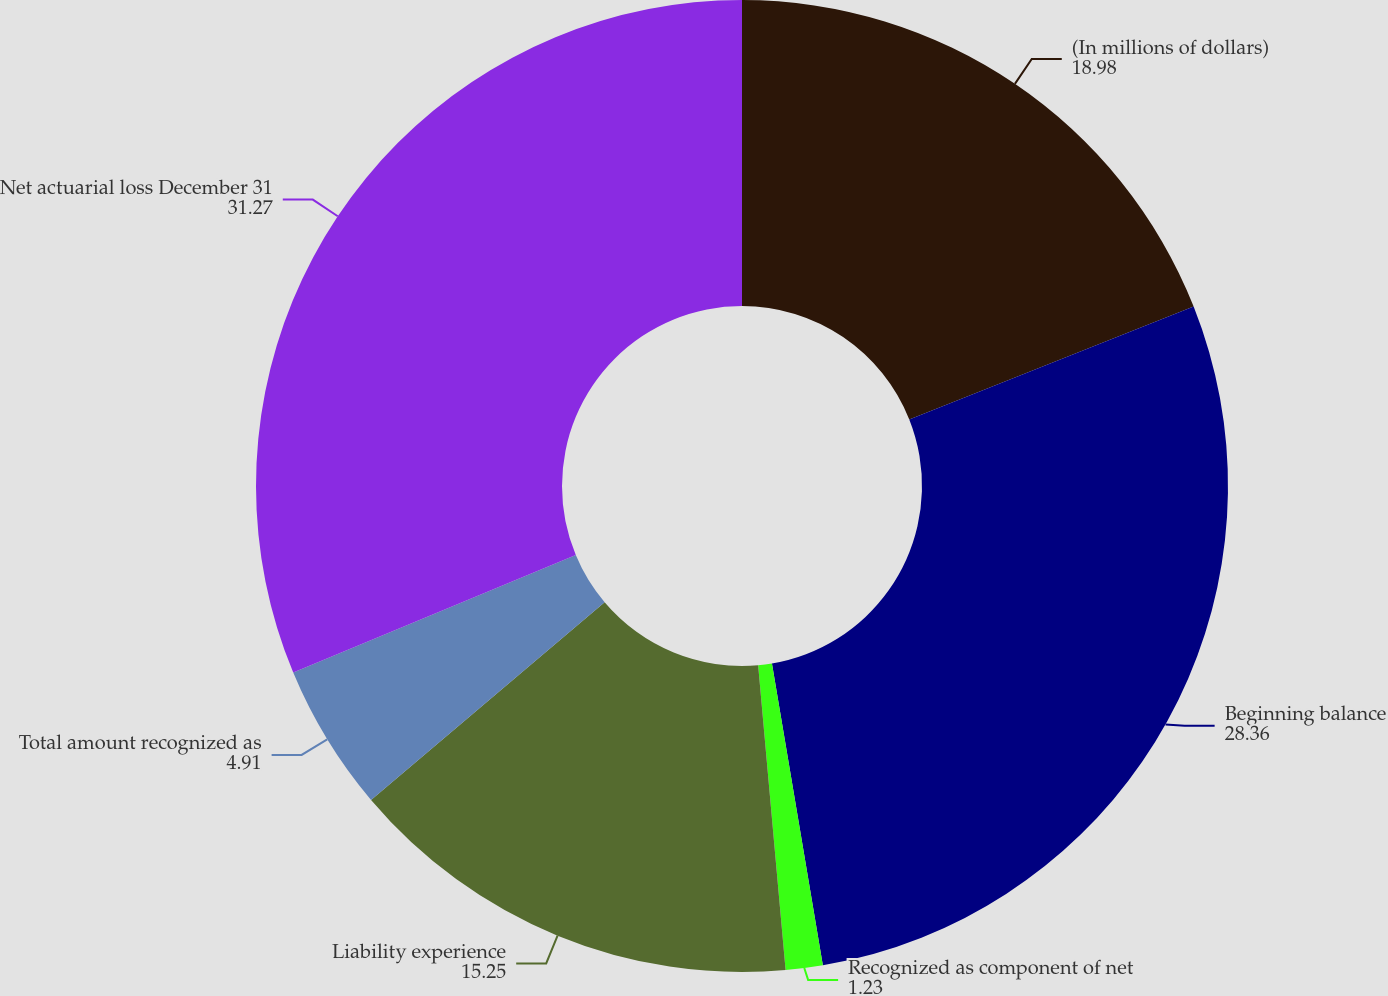Convert chart to OTSL. <chart><loc_0><loc_0><loc_500><loc_500><pie_chart><fcel>(In millions of dollars)<fcel>Beginning balance<fcel>Recognized as component of net<fcel>Liability experience<fcel>Total amount recognized as<fcel>Net actuarial loss December 31<nl><fcel>18.98%<fcel>28.36%<fcel>1.23%<fcel>15.25%<fcel>4.91%<fcel>31.27%<nl></chart> 